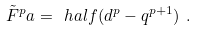<formula> <loc_0><loc_0><loc_500><loc_500>\tilde { F } ^ { p } _ { \ } a = \ h a l f ( d ^ { p } - q ^ { p + 1 } ) \ .</formula> 